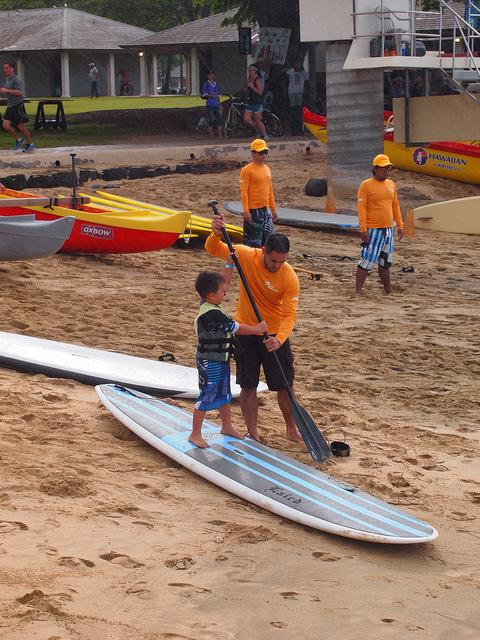The small person here learns how to do what? Please explain your reasoning. paddle board. When there is a ore being used while on a surfing board, it is paddle boarding. 